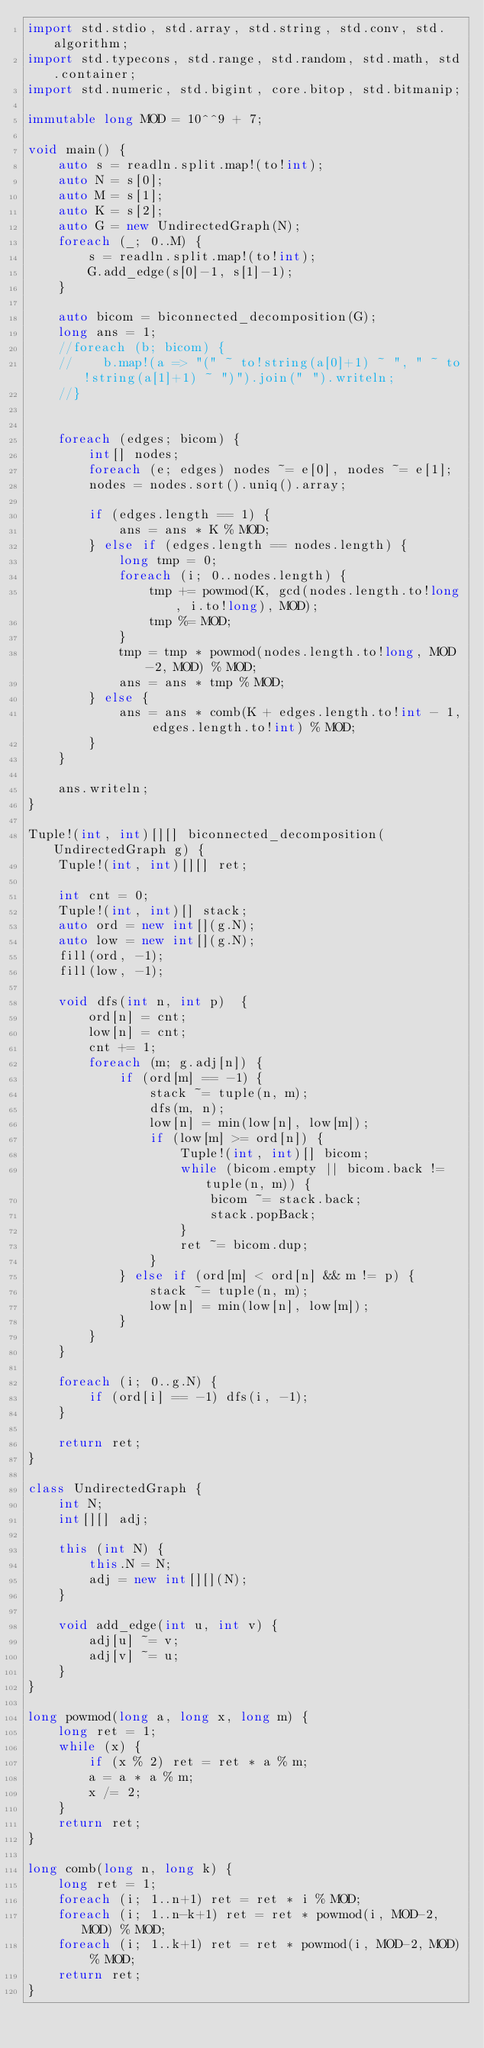<code> <loc_0><loc_0><loc_500><loc_500><_D_>import std.stdio, std.array, std.string, std.conv, std.algorithm;
import std.typecons, std.range, std.random, std.math, std.container;
import std.numeric, std.bigint, core.bitop, std.bitmanip;

immutable long MOD = 10^^9 + 7;

void main() {
    auto s = readln.split.map!(to!int);
    auto N = s[0];
    auto M = s[1];
    auto K = s[2];
    auto G = new UndirectedGraph(N);
    foreach (_; 0..M) {
        s = readln.split.map!(to!int);
        G.add_edge(s[0]-1, s[1]-1);
    }

    auto bicom = biconnected_decomposition(G);
    long ans = 1;
    //foreach (b; bicom) {
    //    b.map!(a => "(" ~ to!string(a[0]+1) ~ ", " ~ to!string(a[1]+1) ~ ")").join(" ").writeln;
    //}


    foreach (edges; bicom) {
        int[] nodes;
        foreach (e; edges) nodes ~= e[0], nodes ~= e[1];
        nodes = nodes.sort().uniq().array;

        if (edges.length == 1) {
            ans = ans * K % MOD;
        } else if (edges.length == nodes.length) {
            long tmp = 0;
            foreach (i; 0..nodes.length) {
                tmp += powmod(K, gcd(nodes.length.to!long, i.to!long), MOD);
                tmp %= MOD;
            }
            tmp = tmp * powmod(nodes.length.to!long, MOD-2, MOD) % MOD;
            ans = ans * tmp % MOD;
        } else {
            ans = ans * comb(K + edges.length.to!int - 1, edges.length.to!int) % MOD;
        }
    }

    ans.writeln;
}

Tuple!(int, int)[][] biconnected_decomposition(UndirectedGraph g) {
    Tuple!(int, int)[][] ret;

    int cnt = 0;
    Tuple!(int, int)[] stack;
    auto ord = new int[](g.N);
    auto low = new int[](g.N);
    fill(ord, -1);
    fill(low, -1);

    void dfs(int n, int p)  {
        ord[n] = cnt;
        low[n] = cnt;
        cnt += 1;
        foreach (m; g.adj[n]) {
            if (ord[m] == -1) {
                stack ~= tuple(n, m);
                dfs(m, n);
                low[n] = min(low[n], low[m]);
                if (low[m] >= ord[n]) {
                    Tuple!(int, int)[] bicom;
                    while (bicom.empty || bicom.back != tuple(n, m)) {
                        bicom ~= stack.back;
                        stack.popBack;
                    }
                    ret ~= bicom.dup;
                }
            } else if (ord[m] < ord[n] && m != p) {
                stack ~= tuple(n, m);
                low[n] = min(low[n], low[m]);
            }
        }
    }

    foreach (i; 0..g.N) {
        if (ord[i] == -1) dfs(i, -1);
    }

    return ret;
}

class UndirectedGraph {
    int N;
    int[][] adj;

    this (int N) {
        this.N = N;
        adj = new int[][](N);
    }

    void add_edge(int u, int v) {
        adj[u] ~= v;
        adj[v] ~= u;
    }
}

long powmod(long a, long x, long m) {
    long ret = 1;
    while (x) {
        if (x % 2) ret = ret * a % m;
        a = a * a % m;
        x /= 2;
    }
    return ret;
}

long comb(long n, long k) {
    long ret = 1;
    foreach (i; 1..n+1) ret = ret * i % MOD;
    foreach (i; 1..n-k+1) ret = ret * powmod(i, MOD-2, MOD) % MOD;
    foreach (i; 1..k+1) ret = ret * powmod(i, MOD-2, MOD) % MOD;
    return ret;
}
</code> 